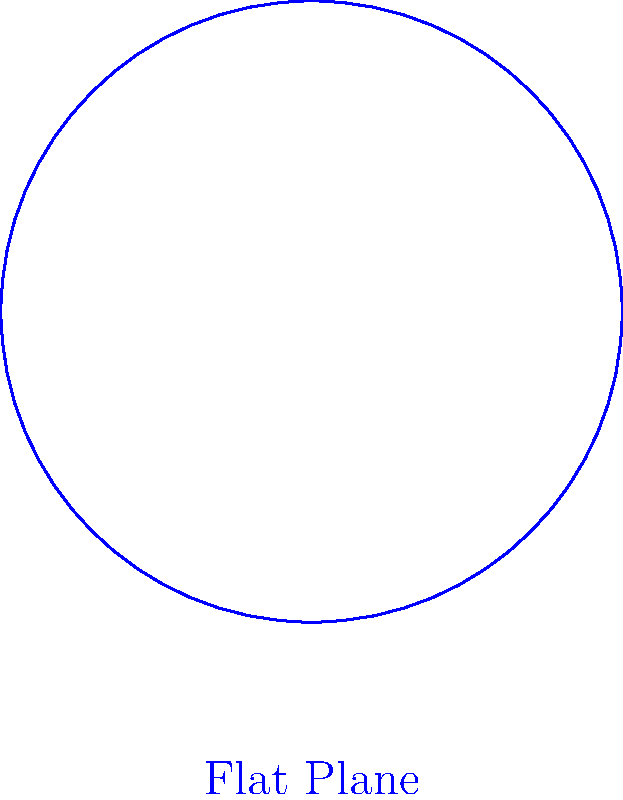As an engineer working on a project involving both flat and curved surfaces, you need to compare the areas of circles with radius R on these different geometries. Consider a circle with radius R on a flat plane and the same circle on a sphere with radius 2R. How does the area of the circle on the sphere compare to the area of the circle on the flat plane? Let's approach this step-by-step:

1) Area of a circle on a flat plane:
   $$A_{flat} = \pi R^2$$

2) On a sphere, we need to use the formula for the area of a spherical cap:
   $$A_{sphere} = 2\pi Rh$$
   where h is the height of the spherical cap.

3) To find h, we can use the chord theorem:
   $$h = R_{sphere} - \sqrt{R_{sphere}^2 - R^2}$$
   where $R_{sphere} = 2R$ (given in the question)

4) Substituting:
   $$h = 2R - \sqrt{(2R)^2 - R^2} = 2R - \sqrt{4R^2 - R^2} = 2R - \sqrt{3R^2} = 2R - R\sqrt{3}$$

5) Now we can calculate the area on the sphere:
   $$A_{sphere} = 2\pi R(2R - R\sqrt{3}) = 2\pi R^2(2 - \sqrt{3})$$

6) The ratio of the areas is:
   $$\frac{A_{sphere}}{A_{flat}} = \frac{2\pi R^2(2 - \sqrt{3})}{\pi R^2} = 2(2 - \sqrt{3}) \approx 0.536$$

7) This means the area on the sphere is about 53.6% of the area on the flat plane.
Answer: The area of the circle on the sphere is $2(2 - \sqrt{3})$ times the area on the flat plane, or approximately 53.6% smaller. 